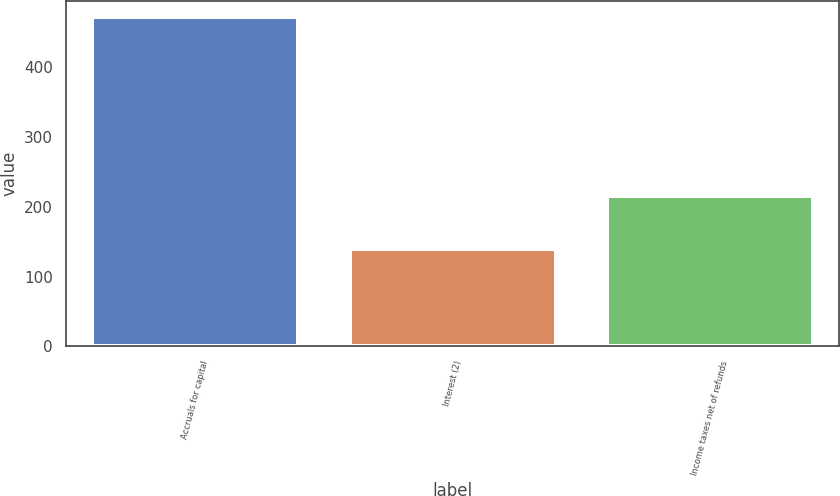<chart> <loc_0><loc_0><loc_500><loc_500><bar_chart><fcel>Accruals for capital<fcel>Interest (2)<fcel>Income taxes net of refunds<nl><fcel>472<fcel>140<fcel>215<nl></chart> 